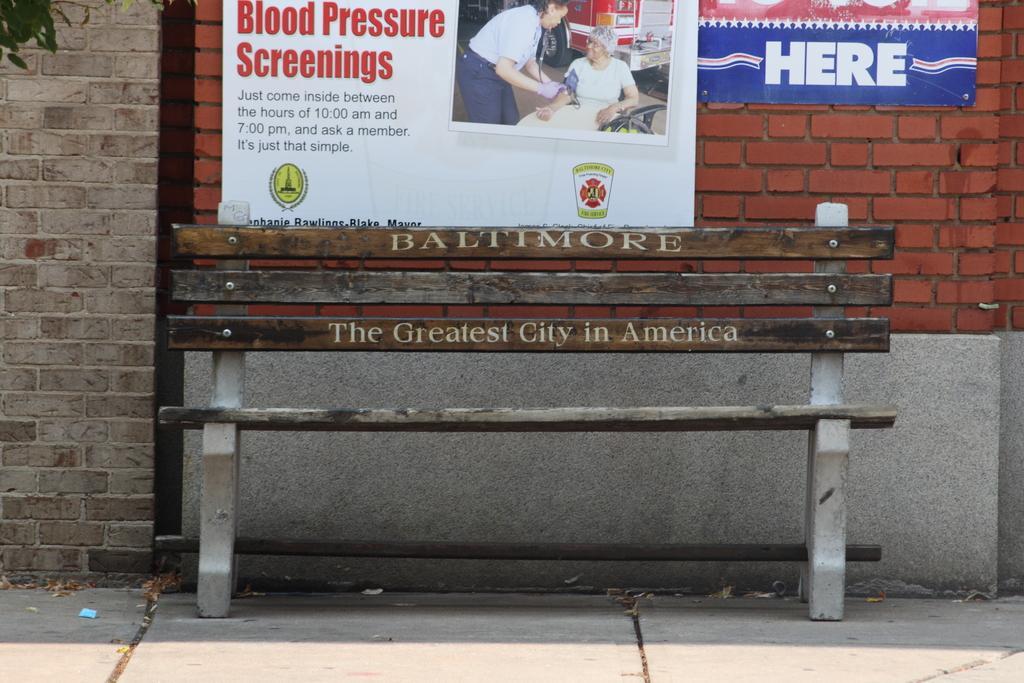In one or two sentences, can you explain what this image depicts? In this image I can see a bench , on the bench I can see a text and back side of the bench I can see the wall and a notice paper attached to the wall , on the notice paper I can see the text and images of persons and I can see in top left leaves visible. 